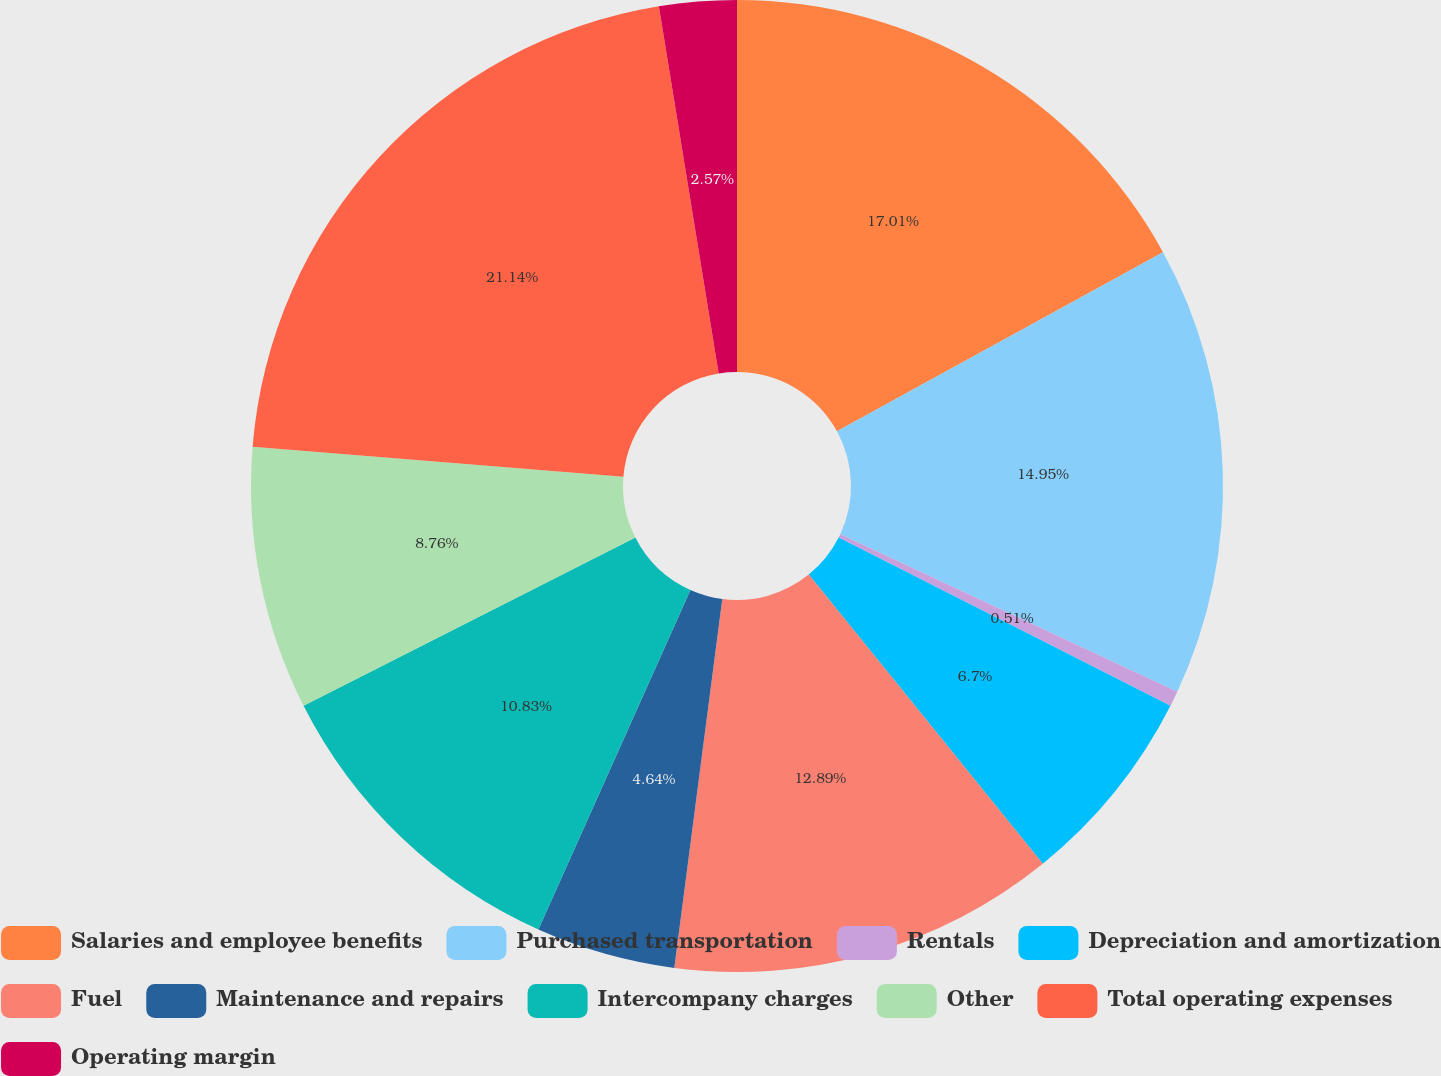Convert chart to OTSL. <chart><loc_0><loc_0><loc_500><loc_500><pie_chart><fcel>Salaries and employee benefits<fcel>Purchased transportation<fcel>Rentals<fcel>Depreciation and amortization<fcel>Fuel<fcel>Maintenance and repairs<fcel>Intercompany charges<fcel>Other<fcel>Total operating expenses<fcel>Operating margin<nl><fcel>17.01%<fcel>14.95%<fcel>0.51%<fcel>6.7%<fcel>12.89%<fcel>4.64%<fcel>10.83%<fcel>8.76%<fcel>21.14%<fcel>2.57%<nl></chart> 